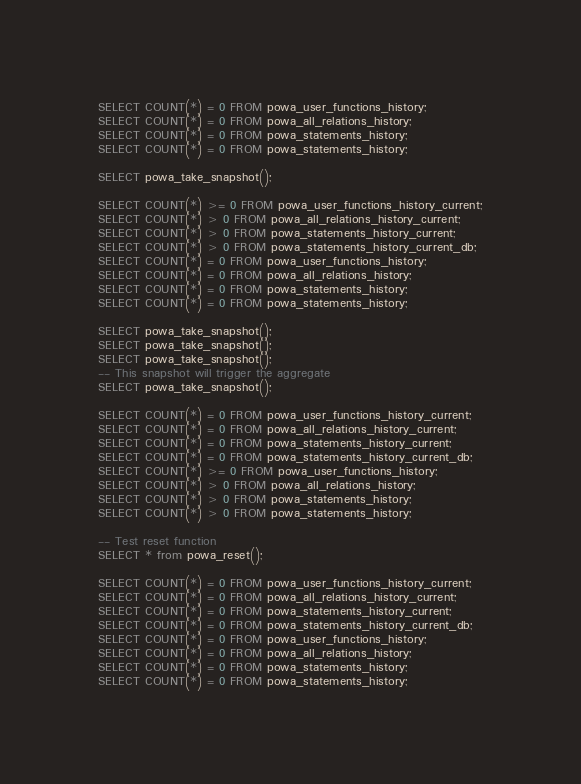Convert code to text. <code><loc_0><loc_0><loc_500><loc_500><_SQL_>SELECT COUNT(*) = 0 FROM powa_user_functions_history;
SELECT COUNT(*) = 0 FROM powa_all_relations_history;
SELECT COUNT(*) = 0 FROM powa_statements_history;
SELECT COUNT(*) = 0 FROM powa_statements_history;

SELECT powa_take_snapshot();

SELECT COUNT(*) >= 0 FROM powa_user_functions_history_current;
SELECT COUNT(*) > 0 FROM powa_all_relations_history_current;
SELECT COUNT(*) > 0 FROM powa_statements_history_current;
SELECT COUNT(*) > 0 FROM powa_statements_history_current_db;
SELECT COUNT(*) = 0 FROM powa_user_functions_history;
SELECT COUNT(*) = 0 FROM powa_all_relations_history;
SELECT COUNT(*) = 0 FROM powa_statements_history;
SELECT COUNT(*) = 0 FROM powa_statements_history;

SELECT powa_take_snapshot();
SELECT powa_take_snapshot();
SELECT powa_take_snapshot();
-- This snapshot will trigger the aggregate
SELECT powa_take_snapshot();

SELECT COUNT(*) = 0 FROM powa_user_functions_history_current;
SELECT COUNT(*) = 0 FROM powa_all_relations_history_current;
SELECT COUNT(*) = 0 FROM powa_statements_history_current;
SELECT COUNT(*) = 0 FROM powa_statements_history_current_db;
SELECT COUNT(*) >= 0 FROM powa_user_functions_history;
SELECT COUNT(*) > 0 FROM powa_all_relations_history;
SELECT COUNT(*) > 0 FROM powa_statements_history;
SELECT COUNT(*) > 0 FROM powa_statements_history;

-- Test reset function
SELECT * from powa_reset();

SELECT COUNT(*) = 0 FROM powa_user_functions_history_current;
SELECT COUNT(*) = 0 FROM powa_all_relations_history_current;
SELECT COUNT(*) = 0 FROM powa_statements_history_current;
SELECT COUNT(*) = 0 FROM powa_statements_history_current_db;
SELECT COUNT(*) = 0 FROM powa_user_functions_history;
SELECT COUNT(*) = 0 FROM powa_all_relations_history;
SELECT COUNT(*) = 0 FROM powa_statements_history;
SELECT COUNT(*) = 0 FROM powa_statements_history;
</code> 